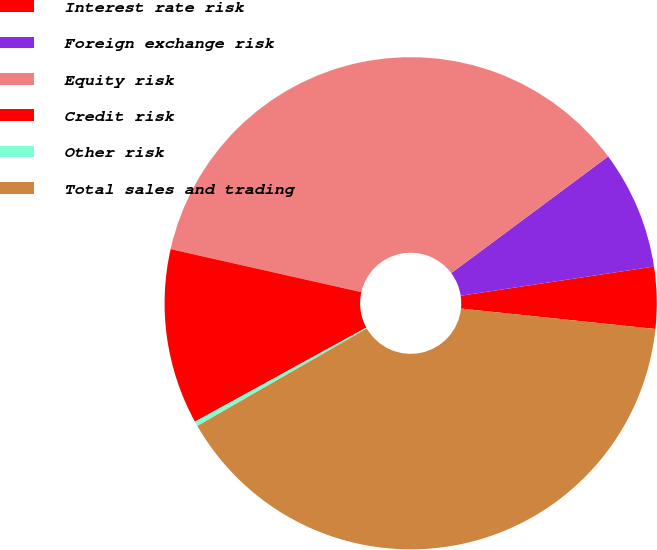<chart> <loc_0><loc_0><loc_500><loc_500><pie_chart><fcel>Interest rate risk<fcel>Foreign exchange risk<fcel>Equity risk<fcel>Credit risk<fcel>Other risk<fcel>Total sales and trading<nl><fcel>4.05%<fcel>7.79%<fcel>36.29%<fcel>11.52%<fcel>0.32%<fcel>40.02%<nl></chart> 